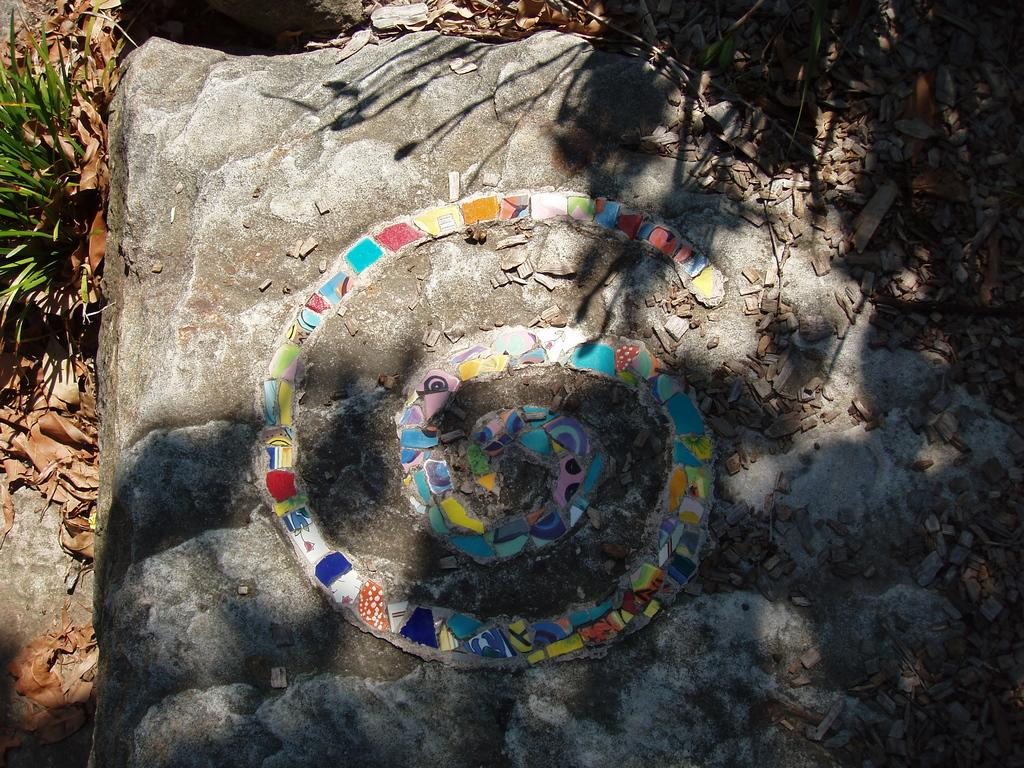What is the main object in the image? There is a stone in the image. What is built on the stone? There is a structure made up of small pieces of stones on the stone. What type of vegetation can be seen on the left side of the image? Dry leaves and grass are visible on the left side of the image. Where else can dry leaves be found in the image? Dry leaves are also visible at the top of the image. How many family members are visible in the image? There are no family members present in the image; it features a stone with a structure made up of small pieces of stones, dry leaves, and grass. Is there any snow visible in the image? There is no snow present in the image; it features a stone with a structure made up of small pieces of stones, dry leaves, and grass. 